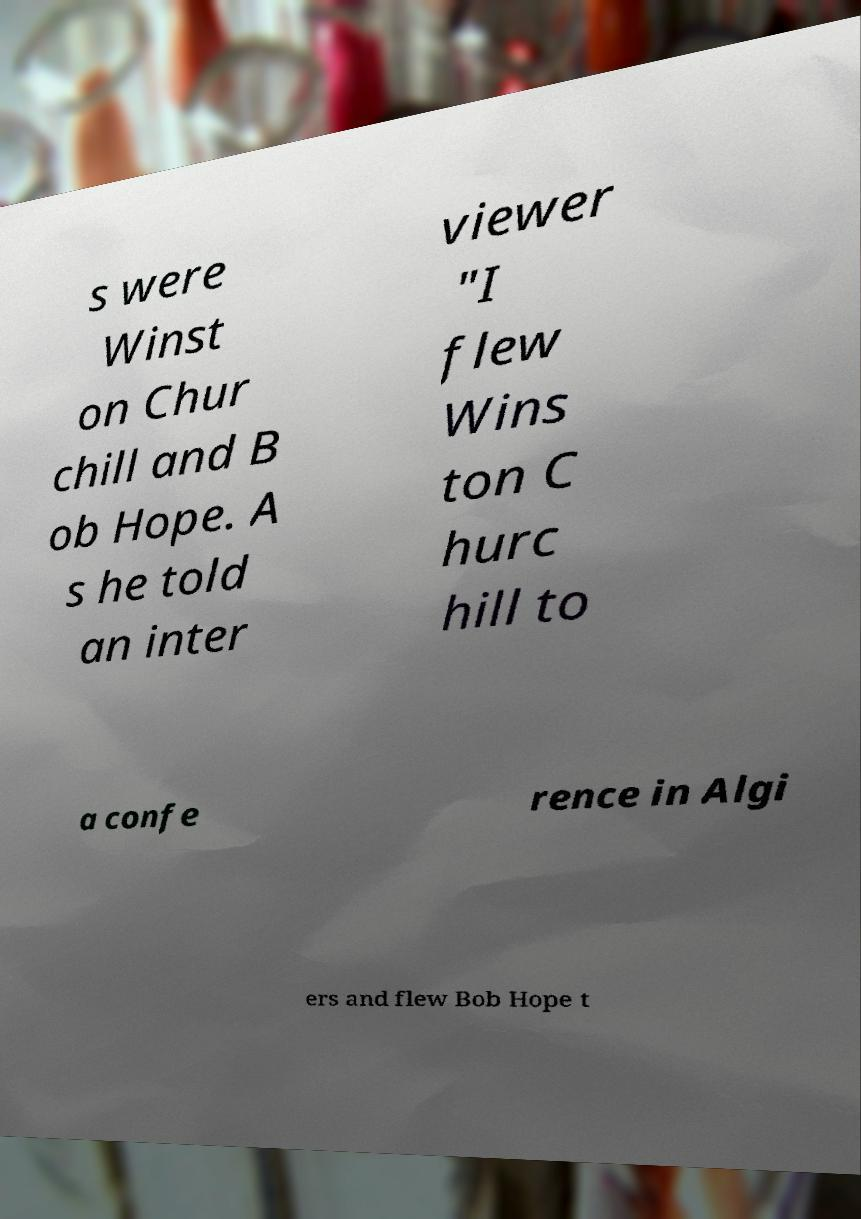Please identify and transcribe the text found in this image. s were Winst on Chur chill and B ob Hope. A s he told an inter viewer "I flew Wins ton C hurc hill to a confe rence in Algi ers and flew Bob Hope t 